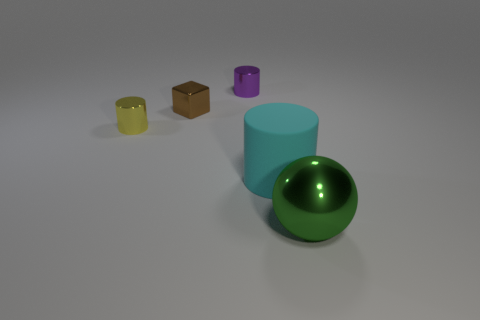Are there fewer small blue rubber cylinders than large cyan cylinders?
Your answer should be compact. Yes. What number of small brown objects have the same material as the yellow thing?
Your answer should be compact. 1. What color is the tiny block that is made of the same material as the green sphere?
Your answer should be compact. Brown. What is the shape of the green thing?
Provide a short and direct response. Sphere. The yellow shiny thing that is the same size as the purple metallic cylinder is what shape?
Give a very brief answer. Cylinder. Are there any purple shiny objects of the same size as the cyan thing?
Your answer should be compact. No. What is the material of the green object that is the same size as the cyan thing?
Keep it short and to the point. Metal. There is a metallic cylinder that is in front of the small thing that is to the right of the small shiny cube; how big is it?
Make the answer very short. Small. There is a metal cylinder that is to the right of the brown metallic block; is its size the same as the big cyan matte object?
Your answer should be very brief. No. Is the number of big green shiny spheres that are in front of the cyan rubber cylinder greater than the number of cyan objects that are on the left side of the yellow thing?
Your answer should be compact. Yes. 